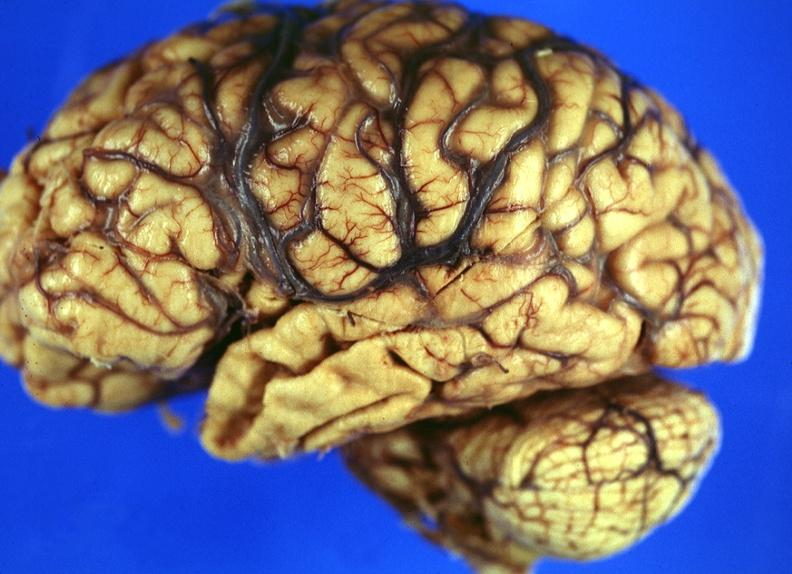s nervous present?
Answer the question using a single word or phrase. Yes 